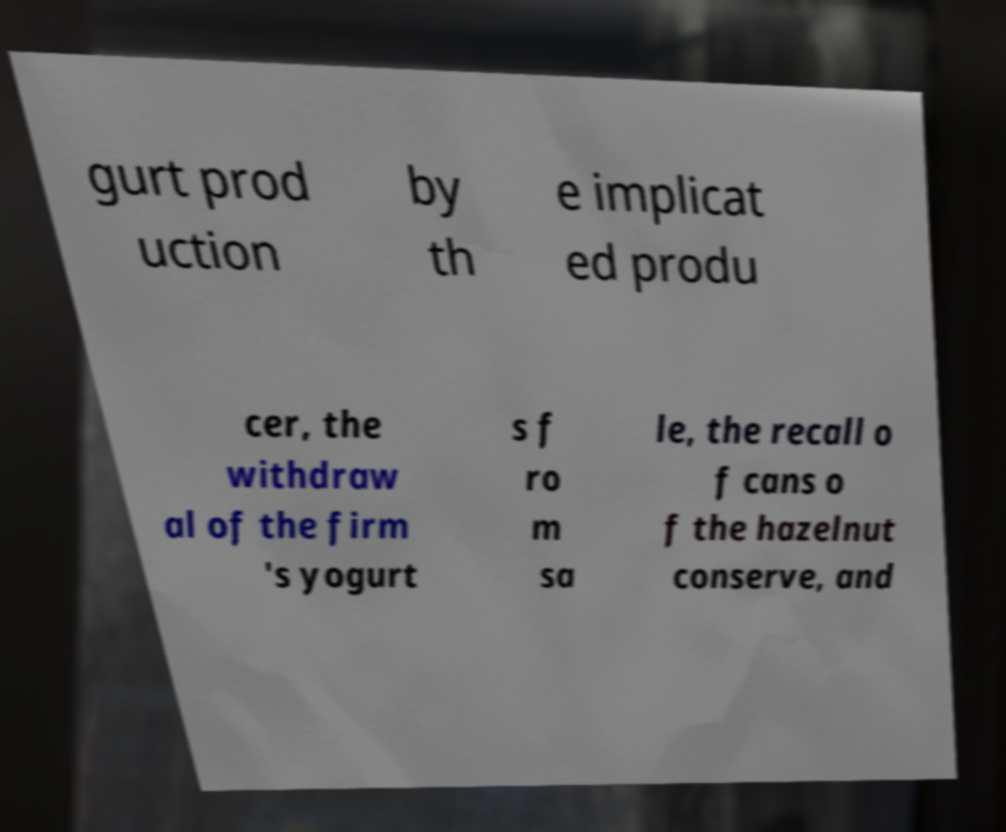Could you assist in decoding the text presented in this image and type it out clearly? gurt prod uction by th e implicat ed produ cer, the withdraw al of the firm 's yogurt s f ro m sa le, the recall o f cans o f the hazelnut conserve, and 